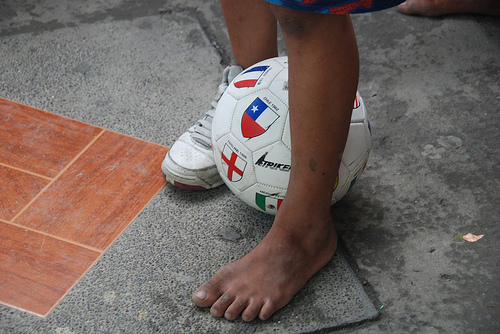<image>
Is there a shoe to the right of the ball? Yes. From this viewpoint, the shoe is positioned to the right side relative to the ball. Is the ball in front of the boy? No. The ball is not in front of the boy. The spatial positioning shows a different relationship between these objects. 